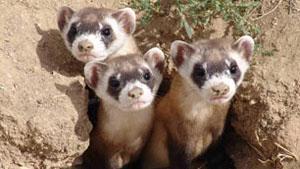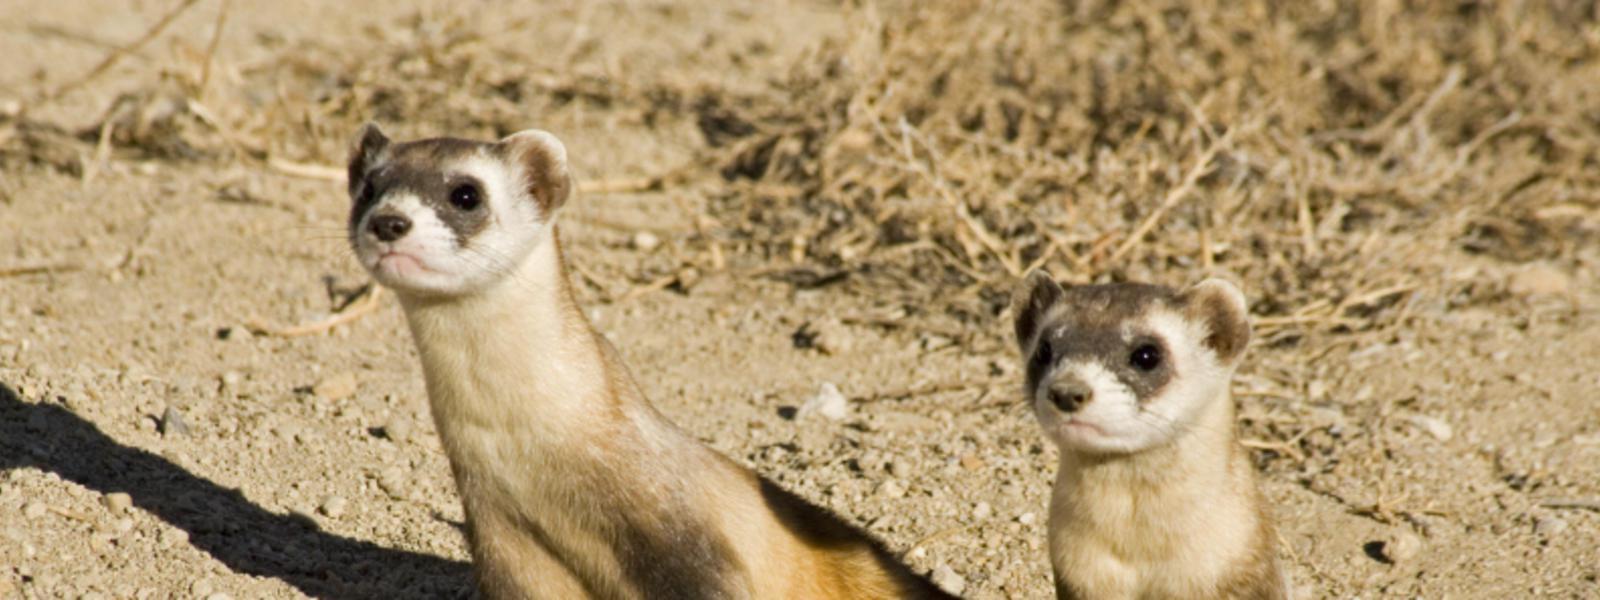The first image is the image on the left, the second image is the image on the right. Assess this claim about the two images: "At least one image has a single animal standing alone.". Correct or not? Answer yes or no. No. The first image is the image on the left, the second image is the image on the right. Assess this claim about the two images: "There are multiple fuzzy animals facing the same direction in each image.". Correct or not? Answer yes or no. Yes. 